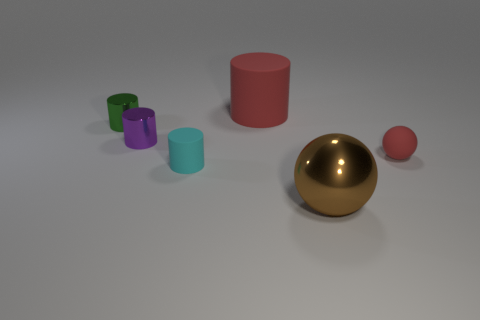Is there a shiny object of the same color as the big cylinder?
Give a very brief answer. No. Is the red cylinder the same size as the purple thing?
Provide a short and direct response. No. Is the color of the large metallic thing the same as the small matte ball?
Provide a short and direct response. No. There is a red thing in front of the red matte thing that is on the left side of the red matte ball; what is it made of?
Offer a very short reply. Rubber. What is the material of the small purple object that is the same shape as the big red rubber object?
Provide a short and direct response. Metal. Does the rubber cylinder that is in front of the purple metallic cylinder have the same size as the purple cylinder?
Provide a succinct answer. Yes. How many metal things are either small green objects or balls?
Keep it short and to the point. 2. There is a thing that is both behind the brown metal object and in front of the matte sphere; what is its material?
Your response must be concise. Rubber. Is the cyan cylinder made of the same material as the small red object?
Keep it short and to the point. Yes. How big is the thing that is both in front of the small rubber sphere and behind the big brown sphere?
Make the answer very short. Small. 